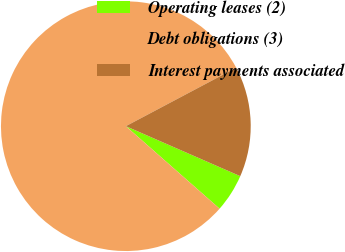Convert chart to OTSL. <chart><loc_0><loc_0><loc_500><loc_500><pie_chart><fcel>Operating leases (2)<fcel>Debt obligations (3)<fcel>Interest payments associated<nl><fcel>4.93%<fcel>80.76%<fcel>14.31%<nl></chart> 